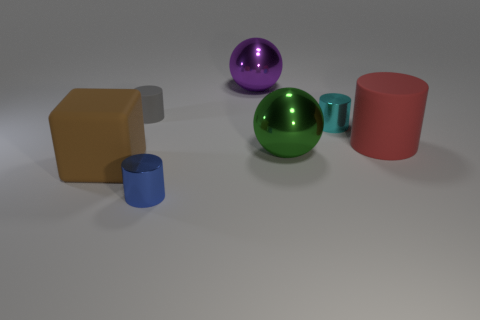Is the size of the ball that is behind the big red matte cylinder the same as the thing that is to the right of the small cyan thing?
Your response must be concise. Yes. There is a metallic object that is to the right of the purple metal ball and behind the green metal thing; how big is it?
Offer a terse response. Small. What color is the big matte thing that is the same shape as the tiny gray matte thing?
Provide a succinct answer. Red. There is a big object that is behind the large brown rubber cube and to the left of the big green metal ball; what shape is it?
Provide a succinct answer. Sphere. There is a cube that is made of the same material as the big red object; what is its color?
Make the answer very short. Brown. There is a gray object that is made of the same material as the large cylinder; what is its shape?
Offer a very short reply. Cylinder. Are there fewer blue metallic things right of the large green metal thing than small purple rubber cubes?
Give a very brief answer. No. There is a tiny cylinder in front of the big block; what is its color?
Provide a succinct answer. Blue. Are there any cyan shiny objects that have the same shape as the red thing?
Offer a very short reply. Yes. What number of large brown shiny things are the same shape as the tiny blue object?
Your response must be concise. 0. 